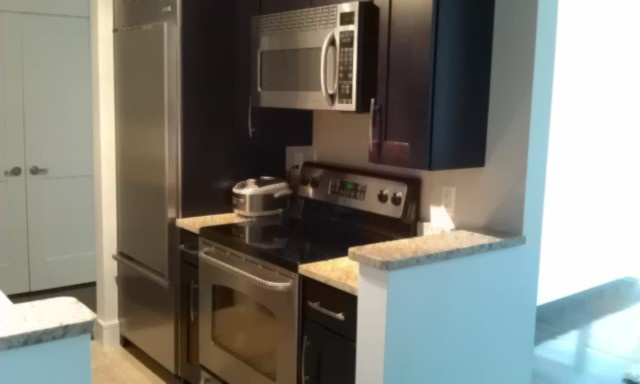Describe the objects in this image and their specific colors. I can see refrigerator in darkgray, black, and gray tones, oven in darkgray, black, maroon, and gray tones, and microwave in darkgray, gray, and black tones in this image. 